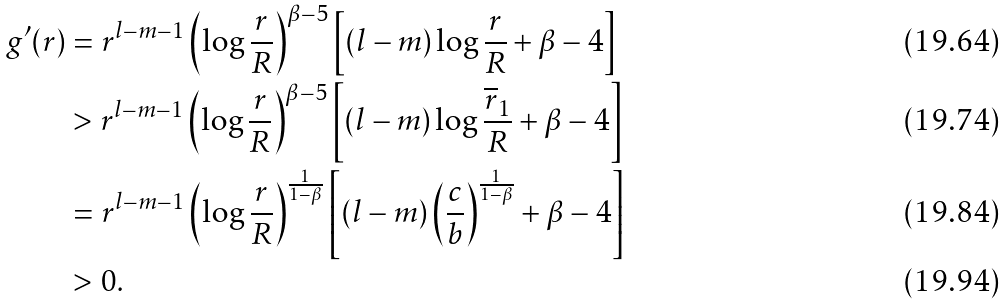<formula> <loc_0><loc_0><loc_500><loc_500>g ^ { \prime } ( r ) & = r ^ { l - m - 1 } \left ( \log \frac { r } { R } \right ) ^ { \beta - 5 } \left [ ( l - m ) \log \frac { r } { R } + \beta - 4 \right ] \\ & > r ^ { l - m - 1 } \left ( \log \frac { r } { R } \right ) ^ { \beta - 5 } \left [ ( l - m ) \log \frac { \overline { r } _ { 1 } } { R } + \beta - 4 \right ] \\ & = r ^ { l - m - 1 } \left ( \log \frac { r } { R } \right ) ^ { \frac { 1 } { 1 - \beta } } \left [ ( l - m ) \left ( \frac { c } { b } \right ) ^ { \frac { 1 } { 1 - \beta } } + \beta - 4 \right ] \\ & > 0 .</formula> 